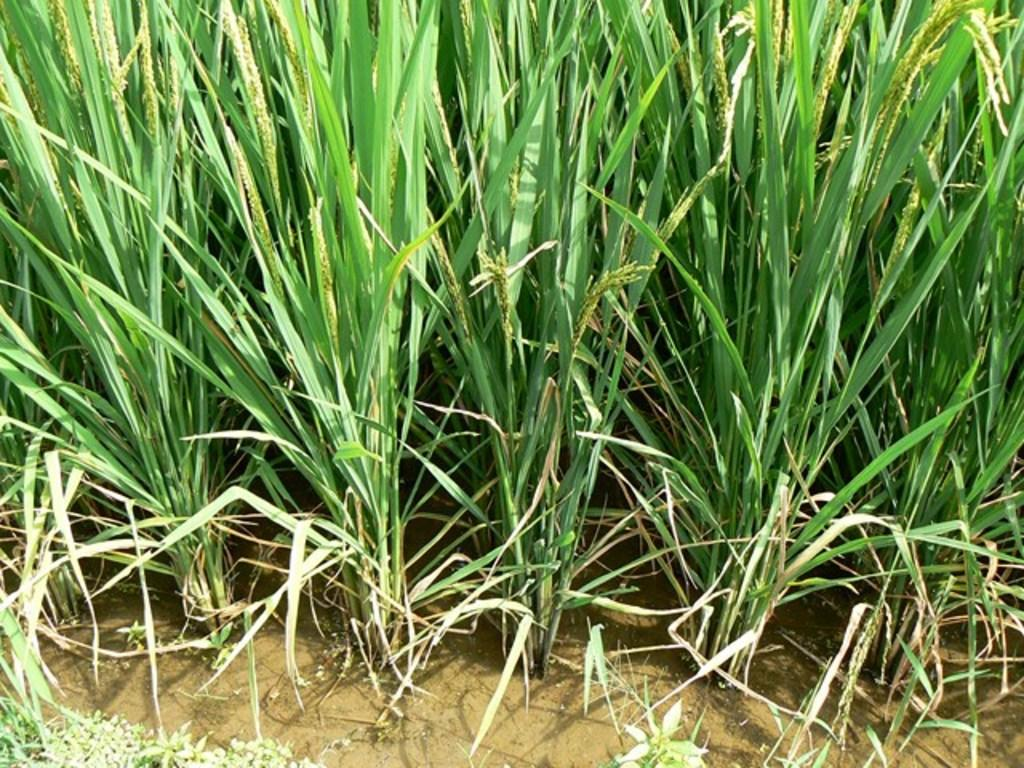What type of plants can be seen in the water in the image? There are grass plants in the water. Can you describe the environment in which the grass plants are located? The grass plants are in the water, which suggests a wet or aquatic environment. What type of bird can be seen flying in the room in the image? There is no bird or room present in the image; it only features grass plants in the water. 